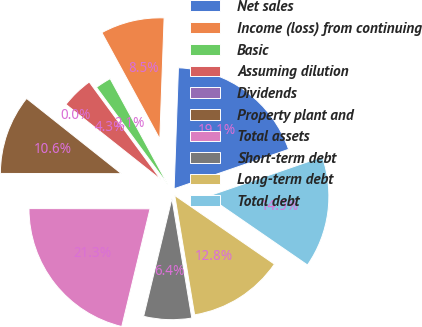Convert chart to OTSL. <chart><loc_0><loc_0><loc_500><loc_500><pie_chart><fcel>Net sales<fcel>Income (loss) from continuing<fcel>Basic<fcel>Assuming dilution<fcel>Dividends<fcel>Property plant and<fcel>Total assets<fcel>Short-term debt<fcel>Long-term debt<fcel>Total debt<nl><fcel>19.15%<fcel>8.51%<fcel>2.13%<fcel>4.26%<fcel>0.0%<fcel>10.64%<fcel>21.28%<fcel>6.38%<fcel>12.77%<fcel>14.89%<nl></chart> 